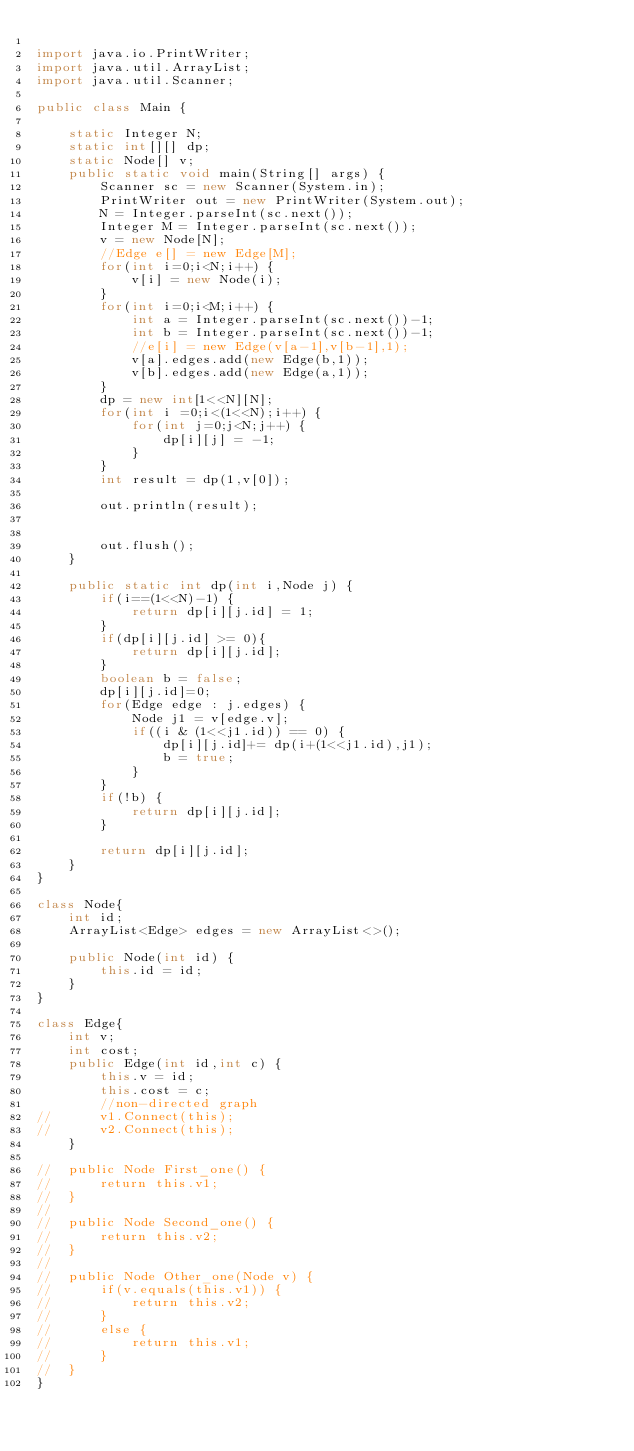Convert code to text. <code><loc_0><loc_0><loc_500><loc_500><_Java_>
import java.io.PrintWriter;
import java.util.ArrayList;
import java.util.Scanner;

public class Main {

	static Integer N;
	static int[][] dp;
	static Node[] v;
	public static void main(String[] args) {
		Scanner sc = new Scanner(System.in);
		PrintWriter out = new PrintWriter(System.out);
		N = Integer.parseInt(sc.next());
		Integer M = Integer.parseInt(sc.next());
		v = new Node[N];
		//Edge e[] = new Edge[M];
		for(int i=0;i<N;i++) {
			v[i] = new Node(i);
		}
		for(int i=0;i<M;i++) {
			int a = Integer.parseInt(sc.next())-1;
			int b = Integer.parseInt(sc.next())-1;
			//e[i] = new Edge(v[a-1],v[b-1],1);
			v[a].edges.add(new Edge(b,1));
			v[b].edges.add(new Edge(a,1));
		}
		dp = new int[1<<N][N];
		for(int i =0;i<(1<<N);i++) {
			for(int j=0;j<N;j++) {
				dp[i][j] = -1;
			}
		}
		int result = dp(1,v[0]);

		out.println(result);


		out.flush();
	}

	public static int dp(int i,Node j) {
		if(i==(1<<N)-1) {
			return dp[i][j.id] = 1;
		}
		if(dp[i][j.id] >= 0){
			return dp[i][j.id];
		}
		boolean b = false;
		dp[i][j.id]=0;
		for(Edge edge : j.edges) {
			Node j1 = v[edge.v];
			if((i & (1<<j1.id)) == 0) {
				dp[i][j.id]+= dp(i+(1<<j1.id),j1);
				b = true;
			}
		}
		if(!b) {
			return dp[i][j.id]; 
		}

		return dp[i][j.id];
	}
}

class Node{
	int id;
	ArrayList<Edge> edges = new ArrayList<>();

	public Node(int id) {
		this.id = id;
	}
}

class Edge{
	int v;
	int cost;
	public Edge(int id,int c) {
		this.v = id;
		this.cost = c;
		//non-directed graph
//		v1.Connect(this);
//		v2.Connect(this);
	}

//	public Node First_one() {
//		return this.v1;
//	}
//
//	public Node Second_one() {
//		return this.v2;
//	}
//
//	public Node Other_one(Node v) {
//		if(v.equals(this.v1)) {
//			return this.v2;
//		}
//		else {
//			return this.v1;
//		}
//	}
}
</code> 